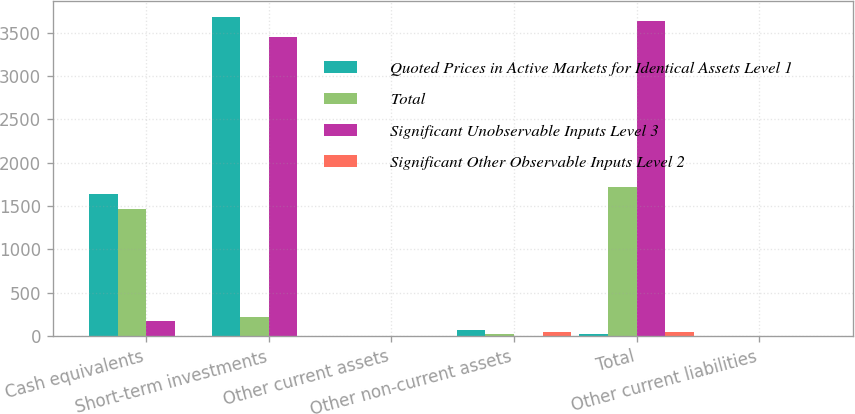<chart> <loc_0><loc_0><loc_500><loc_500><stacked_bar_chart><ecel><fcel>Cash equivalents<fcel>Short-term investments<fcel>Other current assets<fcel>Other non-current assets<fcel>Total<fcel>Other current liabilities<nl><fcel>Quoted Prices in Active Markets for Identical Assets Level 1<fcel>1642.4<fcel>3675.5<fcel>2.8<fcel>68.7<fcel>26.7<fcel>3.1<nl><fcel>Total<fcel>1463.1<fcel>222.9<fcel>1.6<fcel>26.7<fcel>1714.3<fcel>0<nl><fcel>Significant Unobservable Inputs Level 3<fcel>179.3<fcel>3452.6<fcel>1.2<fcel>0<fcel>3633.1<fcel>3.1<nl><fcel>Significant Other Observable Inputs Level 2<fcel>0<fcel>0<fcel>0<fcel>42<fcel>42<fcel>0<nl></chart> 